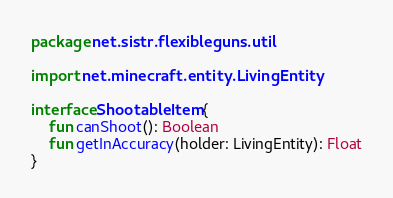Convert code to text. <code><loc_0><loc_0><loc_500><loc_500><_Kotlin_>package net.sistr.flexibleguns.util

import net.minecraft.entity.LivingEntity

interface ShootableItem {
    fun canShoot(): Boolean
    fun getInAccuracy(holder: LivingEntity): Float
}</code> 